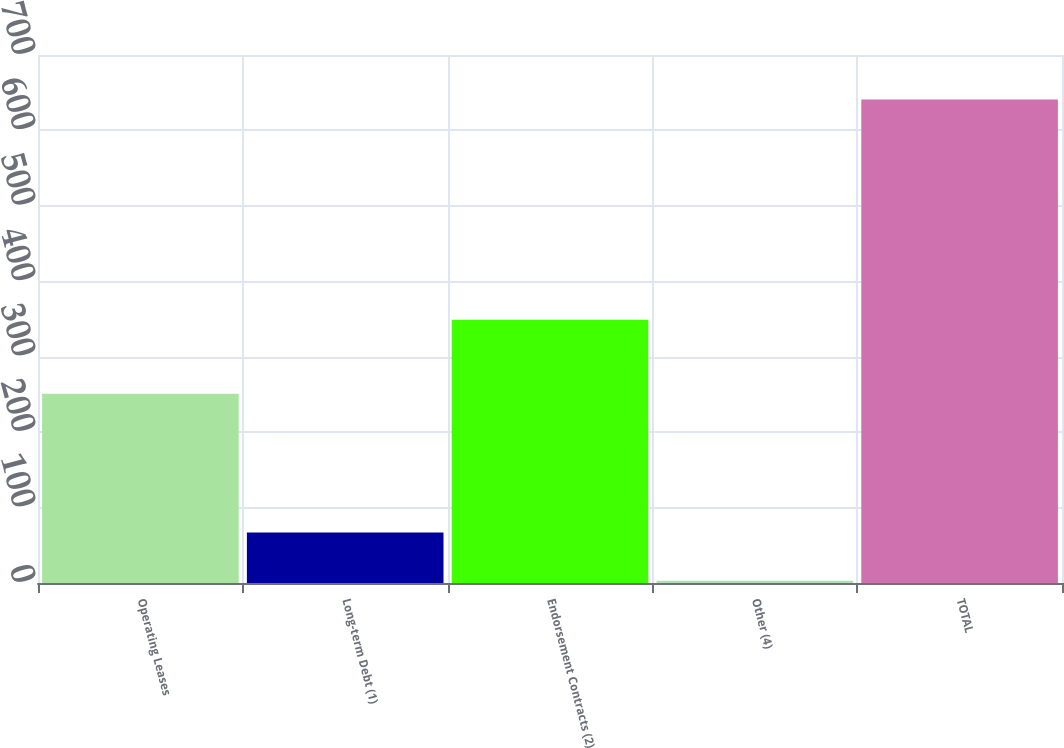Convert chart to OTSL. <chart><loc_0><loc_0><loc_500><loc_500><bar_chart><fcel>Operating Leases<fcel>Long-term Debt (1)<fcel>Endorsement Contracts (2)<fcel>Other (4)<fcel>TOTAL<nl><fcel>251<fcel>66.8<fcel>349<fcel>3<fcel>641<nl></chart> 